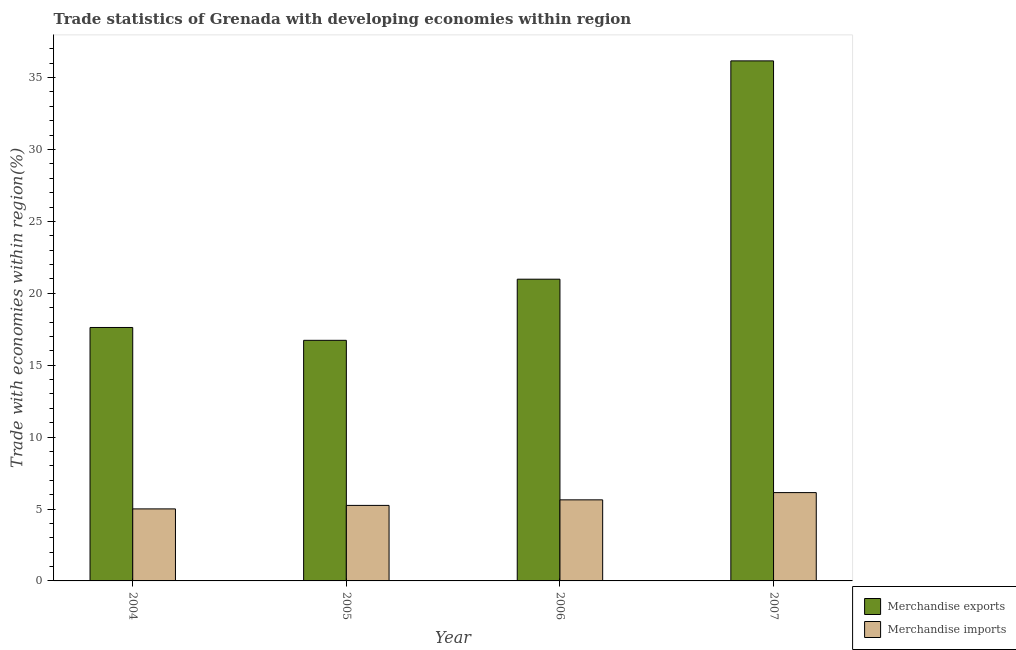How many different coloured bars are there?
Your response must be concise. 2. How many bars are there on the 3rd tick from the right?
Your answer should be compact. 2. What is the label of the 1st group of bars from the left?
Provide a short and direct response. 2004. In how many cases, is the number of bars for a given year not equal to the number of legend labels?
Offer a terse response. 0. What is the merchandise imports in 2007?
Keep it short and to the point. 6.14. Across all years, what is the maximum merchandise imports?
Ensure brevity in your answer.  6.14. Across all years, what is the minimum merchandise exports?
Offer a terse response. 16.73. In which year was the merchandise imports maximum?
Your answer should be compact. 2007. In which year was the merchandise imports minimum?
Your answer should be compact. 2004. What is the total merchandise imports in the graph?
Your answer should be compact. 22.04. What is the difference between the merchandise imports in 2004 and that in 2005?
Provide a succinct answer. -0.24. What is the difference between the merchandise exports in 2005 and the merchandise imports in 2006?
Provide a succinct answer. -4.25. What is the average merchandise exports per year?
Keep it short and to the point. 22.88. What is the ratio of the merchandise exports in 2004 to that in 2007?
Ensure brevity in your answer.  0.49. Is the merchandise imports in 2006 less than that in 2007?
Your response must be concise. Yes. Is the difference between the merchandise exports in 2004 and 2005 greater than the difference between the merchandise imports in 2004 and 2005?
Keep it short and to the point. No. What is the difference between the highest and the second highest merchandise imports?
Your response must be concise. 0.5. What is the difference between the highest and the lowest merchandise imports?
Ensure brevity in your answer.  1.13. Is the sum of the merchandise exports in 2005 and 2007 greater than the maximum merchandise imports across all years?
Give a very brief answer. Yes. Are all the bars in the graph horizontal?
Provide a succinct answer. No. What is the difference between two consecutive major ticks on the Y-axis?
Offer a very short reply. 5. Does the graph contain grids?
Make the answer very short. No. How many legend labels are there?
Offer a terse response. 2. How are the legend labels stacked?
Your answer should be compact. Vertical. What is the title of the graph?
Offer a terse response. Trade statistics of Grenada with developing economies within region. What is the label or title of the X-axis?
Provide a succinct answer. Year. What is the label or title of the Y-axis?
Give a very brief answer. Trade with economies within region(%). What is the Trade with economies within region(%) of Merchandise exports in 2004?
Your response must be concise. 17.62. What is the Trade with economies within region(%) in Merchandise imports in 2004?
Your answer should be very brief. 5.01. What is the Trade with economies within region(%) of Merchandise exports in 2005?
Your answer should be very brief. 16.73. What is the Trade with economies within region(%) in Merchandise imports in 2005?
Offer a terse response. 5.25. What is the Trade with economies within region(%) in Merchandise exports in 2006?
Provide a succinct answer. 20.98. What is the Trade with economies within region(%) of Merchandise imports in 2006?
Your answer should be compact. 5.64. What is the Trade with economies within region(%) in Merchandise exports in 2007?
Make the answer very short. 36.16. What is the Trade with economies within region(%) of Merchandise imports in 2007?
Give a very brief answer. 6.14. Across all years, what is the maximum Trade with economies within region(%) in Merchandise exports?
Offer a terse response. 36.16. Across all years, what is the maximum Trade with economies within region(%) in Merchandise imports?
Make the answer very short. 6.14. Across all years, what is the minimum Trade with economies within region(%) of Merchandise exports?
Your answer should be very brief. 16.73. Across all years, what is the minimum Trade with economies within region(%) in Merchandise imports?
Make the answer very short. 5.01. What is the total Trade with economies within region(%) in Merchandise exports in the graph?
Provide a short and direct response. 91.5. What is the total Trade with economies within region(%) of Merchandise imports in the graph?
Your answer should be compact. 22.04. What is the difference between the Trade with economies within region(%) in Merchandise exports in 2004 and that in 2005?
Make the answer very short. 0.89. What is the difference between the Trade with economies within region(%) in Merchandise imports in 2004 and that in 2005?
Ensure brevity in your answer.  -0.24. What is the difference between the Trade with economies within region(%) in Merchandise exports in 2004 and that in 2006?
Offer a terse response. -3.36. What is the difference between the Trade with economies within region(%) of Merchandise imports in 2004 and that in 2006?
Offer a very short reply. -0.63. What is the difference between the Trade with economies within region(%) in Merchandise exports in 2004 and that in 2007?
Your answer should be compact. -18.54. What is the difference between the Trade with economies within region(%) in Merchandise imports in 2004 and that in 2007?
Your response must be concise. -1.13. What is the difference between the Trade with economies within region(%) of Merchandise exports in 2005 and that in 2006?
Ensure brevity in your answer.  -4.25. What is the difference between the Trade with economies within region(%) in Merchandise imports in 2005 and that in 2006?
Offer a very short reply. -0.39. What is the difference between the Trade with economies within region(%) in Merchandise exports in 2005 and that in 2007?
Offer a very short reply. -19.43. What is the difference between the Trade with economies within region(%) of Merchandise imports in 2005 and that in 2007?
Offer a very short reply. -0.89. What is the difference between the Trade with economies within region(%) in Merchandise exports in 2006 and that in 2007?
Offer a very short reply. -15.18. What is the difference between the Trade with economies within region(%) of Merchandise imports in 2006 and that in 2007?
Make the answer very short. -0.5. What is the difference between the Trade with economies within region(%) in Merchandise exports in 2004 and the Trade with economies within region(%) in Merchandise imports in 2005?
Your response must be concise. 12.37. What is the difference between the Trade with economies within region(%) of Merchandise exports in 2004 and the Trade with economies within region(%) of Merchandise imports in 2006?
Offer a very short reply. 11.99. What is the difference between the Trade with economies within region(%) in Merchandise exports in 2004 and the Trade with economies within region(%) in Merchandise imports in 2007?
Give a very brief answer. 11.48. What is the difference between the Trade with economies within region(%) in Merchandise exports in 2005 and the Trade with economies within region(%) in Merchandise imports in 2006?
Your answer should be compact. 11.09. What is the difference between the Trade with economies within region(%) in Merchandise exports in 2005 and the Trade with economies within region(%) in Merchandise imports in 2007?
Ensure brevity in your answer.  10.59. What is the difference between the Trade with economies within region(%) of Merchandise exports in 2006 and the Trade with economies within region(%) of Merchandise imports in 2007?
Offer a terse response. 14.84. What is the average Trade with economies within region(%) in Merchandise exports per year?
Give a very brief answer. 22.88. What is the average Trade with economies within region(%) of Merchandise imports per year?
Ensure brevity in your answer.  5.51. In the year 2004, what is the difference between the Trade with economies within region(%) of Merchandise exports and Trade with economies within region(%) of Merchandise imports?
Provide a short and direct response. 12.62. In the year 2005, what is the difference between the Trade with economies within region(%) of Merchandise exports and Trade with economies within region(%) of Merchandise imports?
Your answer should be very brief. 11.48. In the year 2006, what is the difference between the Trade with economies within region(%) in Merchandise exports and Trade with economies within region(%) in Merchandise imports?
Ensure brevity in your answer.  15.35. In the year 2007, what is the difference between the Trade with economies within region(%) of Merchandise exports and Trade with economies within region(%) of Merchandise imports?
Make the answer very short. 30.02. What is the ratio of the Trade with economies within region(%) of Merchandise exports in 2004 to that in 2005?
Ensure brevity in your answer.  1.05. What is the ratio of the Trade with economies within region(%) in Merchandise imports in 2004 to that in 2005?
Give a very brief answer. 0.95. What is the ratio of the Trade with economies within region(%) in Merchandise exports in 2004 to that in 2006?
Offer a terse response. 0.84. What is the ratio of the Trade with economies within region(%) in Merchandise imports in 2004 to that in 2006?
Your answer should be compact. 0.89. What is the ratio of the Trade with economies within region(%) in Merchandise exports in 2004 to that in 2007?
Provide a short and direct response. 0.49. What is the ratio of the Trade with economies within region(%) in Merchandise imports in 2004 to that in 2007?
Your response must be concise. 0.82. What is the ratio of the Trade with economies within region(%) in Merchandise exports in 2005 to that in 2006?
Give a very brief answer. 0.8. What is the ratio of the Trade with economies within region(%) in Merchandise imports in 2005 to that in 2006?
Ensure brevity in your answer.  0.93. What is the ratio of the Trade with economies within region(%) of Merchandise exports in 2005 to that in 2007?
Provide a short and direct response. 0.46. What is the ratio of the Trade with economies within region(%) of Merchandise imports in 2005 to that in 2007?
Make the answer very short. 0.86. What is the ratio of the Trade with economies within region(%) of Merchandise exports in 2006 to that in 2007?
Keep it short and to the point. 0.58. What is the ratio of the Trade with economies within region(%) of Merchandise imports in 2006 to that in 2007?
Your response must be concise. 0.92. What is the difference between the highest and the second highest Trade with economies within region(%) in Merchandise exports?
Your answer should be very brief. 15.18. What is the difference between the highest and the second highest Trade with economies within region(%) in Merchandise imports?
Provide a short and direct response. 0.5. What is the difference between the highest and the lowest Trade with economies within region(%) of Merchandise exports?
Provide a short and direct response. 19.43. What is the difference between the highest and the lowest Trade with economies within region(%) in Merchandise imports?
Provide a succinct answer. 1.13. 